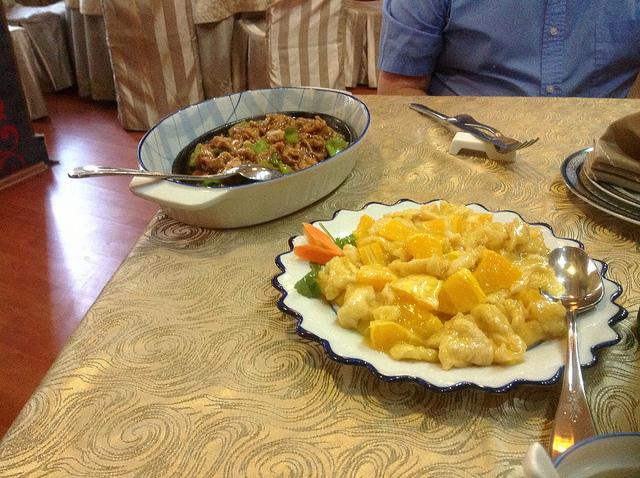What color is the man's shirt?
Concise answer only. Blue. Which item will be eaten with the spoon?
Keep it brief. Casserole. What is mainly featured?
Be succinct. Food. What is the substance in the bowl?
Quick response, please. Food. What are the yellow things?
Keep it brief. Dumplings. Which dish holds an upside down spoon?
Concise answer only. Meat dish. How many prongs are on the fork?
Write a very short answer. 4. Is this in their home?
Write a very short answer. Yes. 